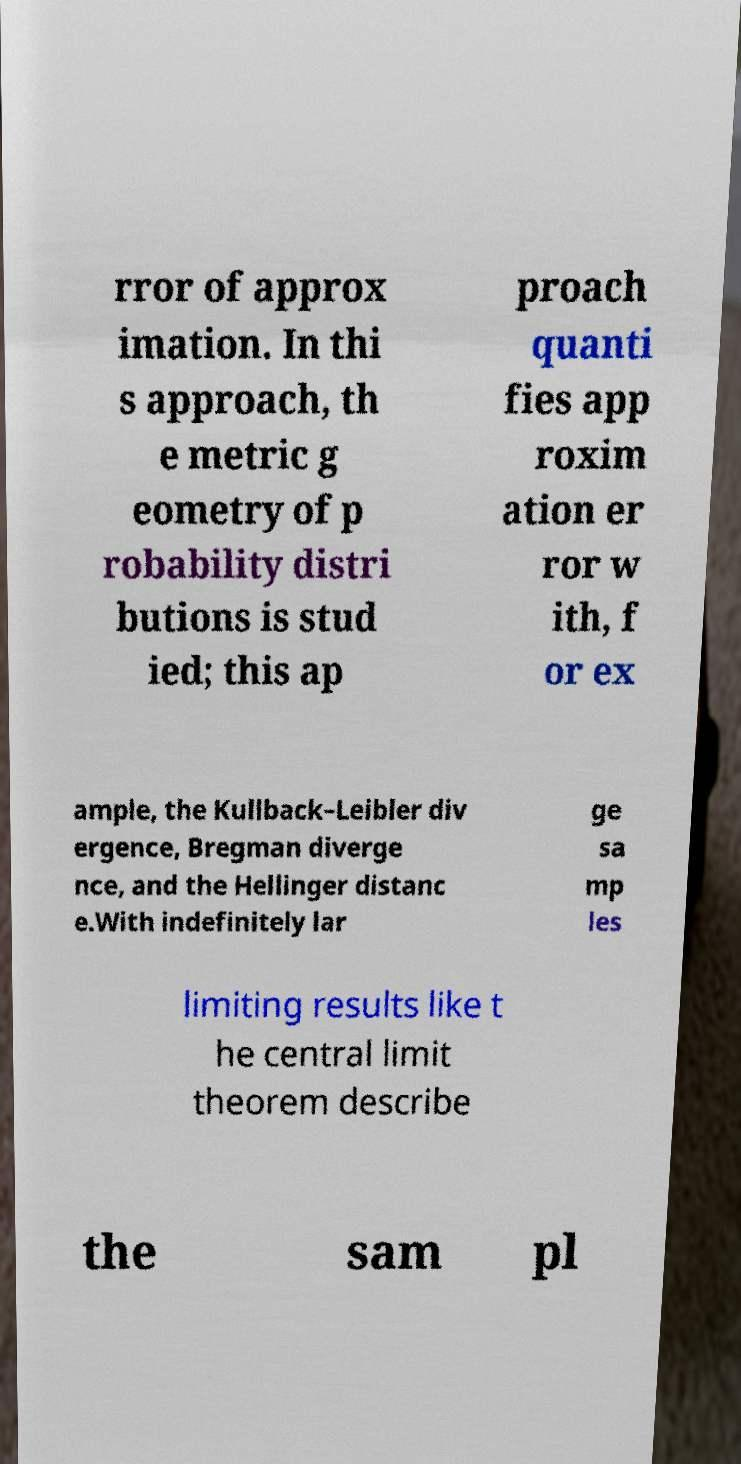For documentation purposes, I need the text within this image transcribed. Could you provide that? rror of approx imation. In thi s approach, th e metric g eometry of p robability distri butions is stud ied; this ap proach quanti fies app roxim ation er ror w ith, f or ex ample, the Kullback–Leibler div ergence, Bregman diverge nce, and the Hellinger distanc e.With indefinitely lar ge sa mp les limiting results like t he central limit theorem describe the sam pl 